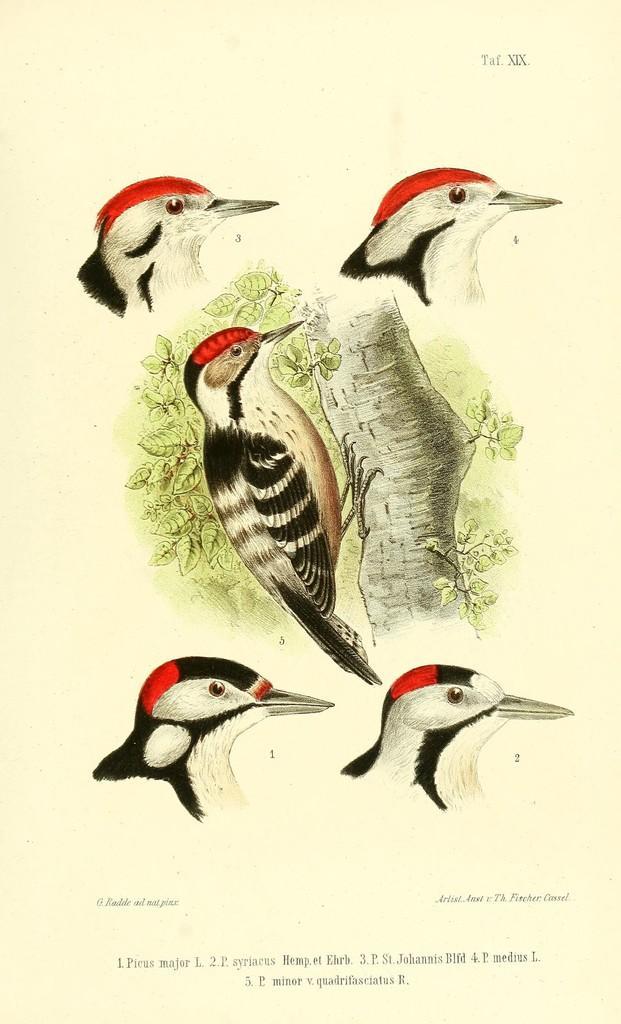How would you summarize this image in a sentence or two? In this picture we can see a paper, there is a bark of a tree, a bird and some leaves on the paper, at the bottom there is some text, we can also see heads of birds. 